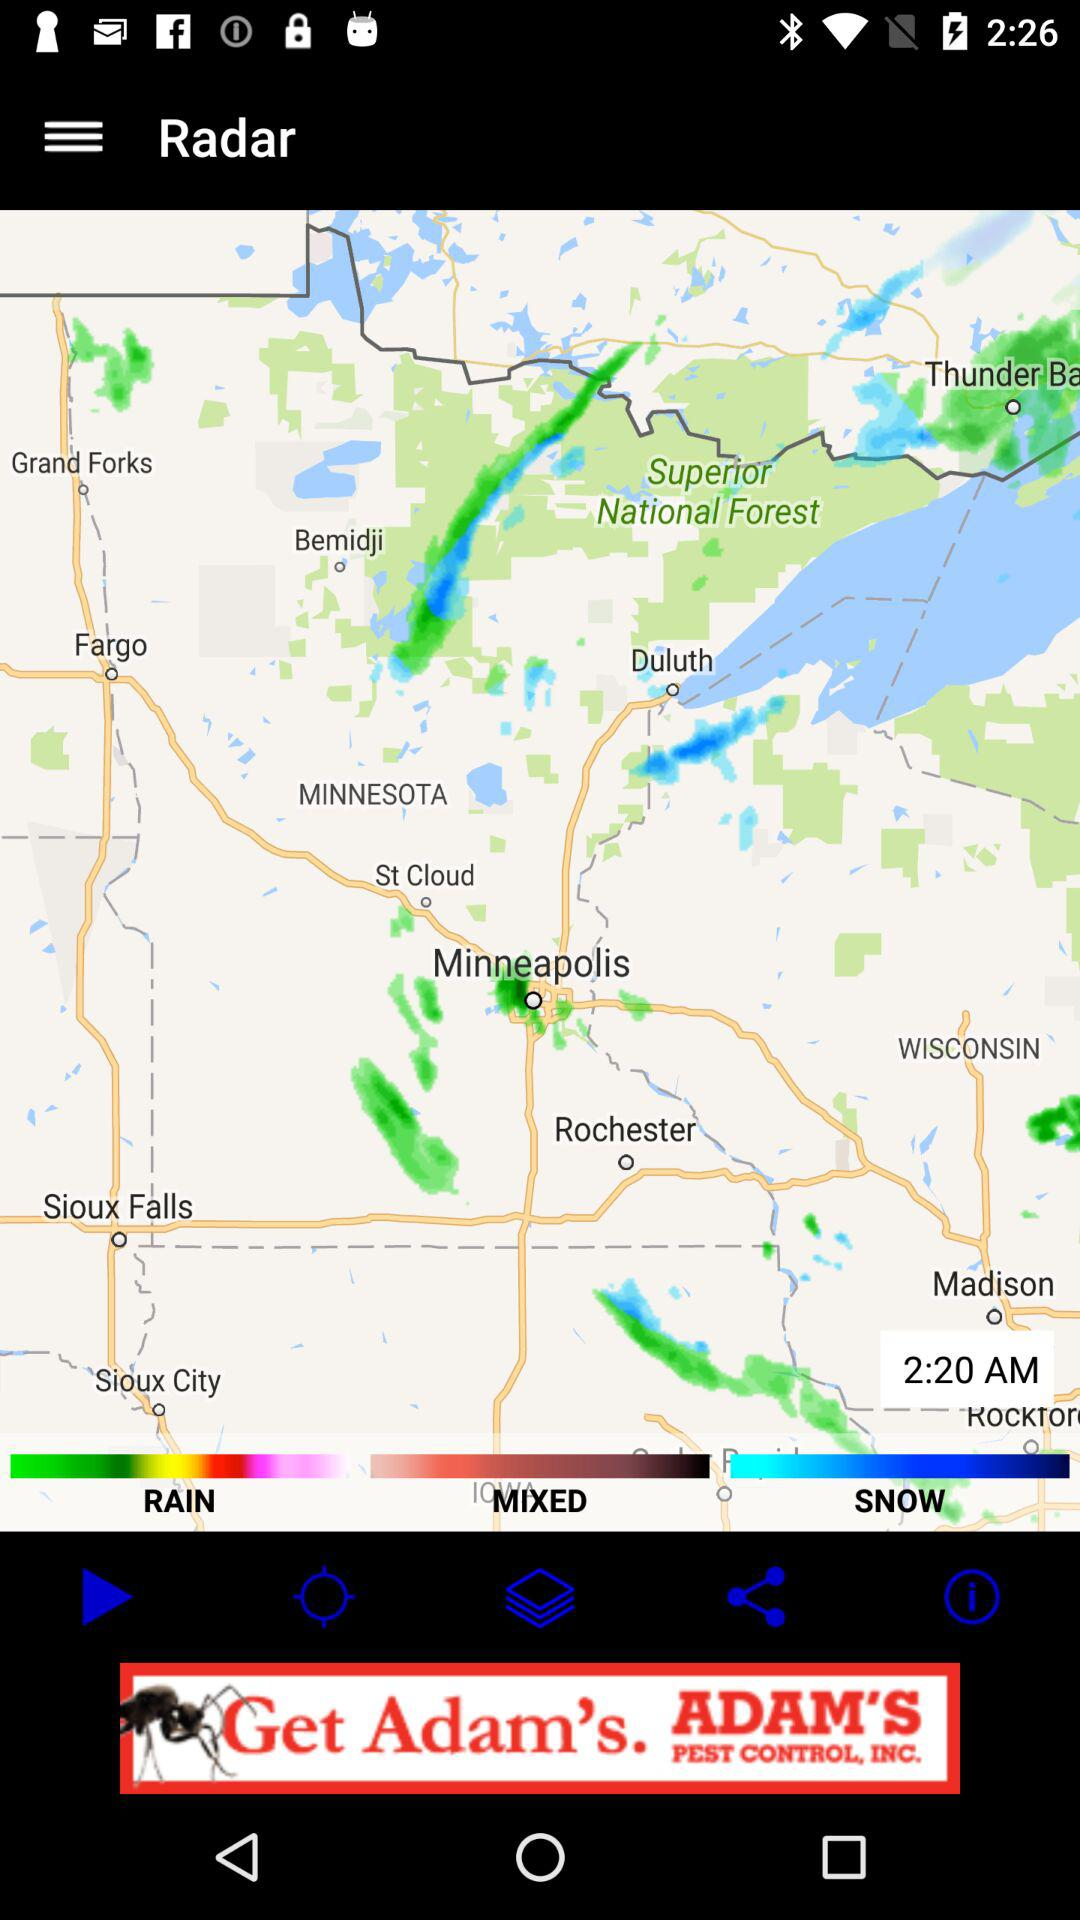What is the time shown on the map? The time shown on the map is 2:20 AM. 